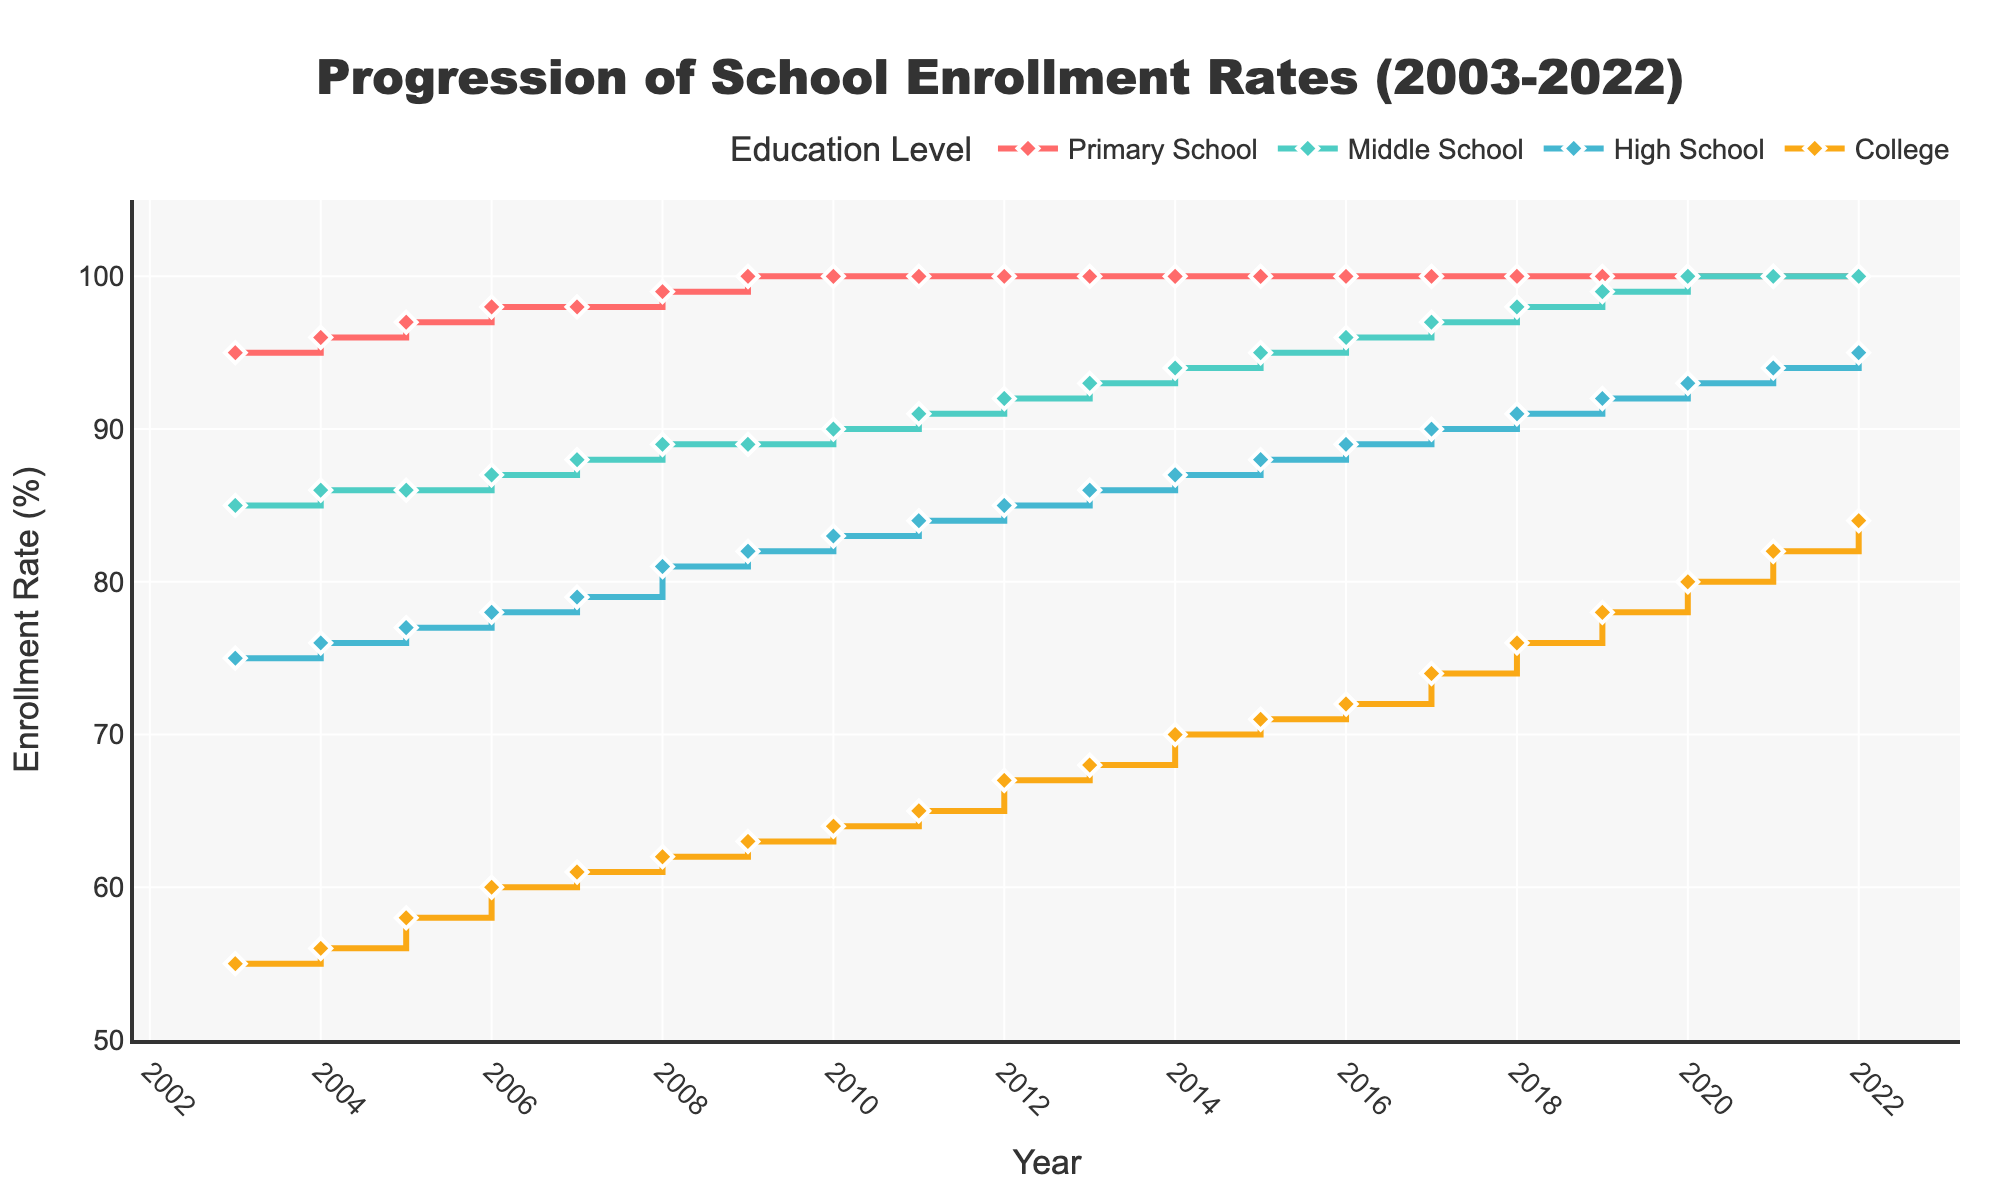what is the range of the y-axis on the figure? The y-axis runs from 50 to 105 percent, as shown by the axis labels and tick marks
Answer: 50 to 105 how does the enrollment rate for high school change from 2008 to 2012? In 2008, the rate is 81%. In 2012, it's 85%. The difference is 85% - 81% = 4%
Answer: 4% increase which education level has consistently reached full enrollment over the years? Observing the lines, the Primary School level reaches 100% enrollment consistently from 2009 onward
Answer: Primary School between what years did the middle school enrollment rate increase from 86% to 92%? Middle School enrollment rate increased from 86% in 2004 to 92% in 2012
Answer: 2004 to 2012 in what year did middle school and high school enrollment rates both reach 100%? In 2020, both Middle School and High School lines hit 100% as seen in the markers
Answer: 2020 how many years did it take for college enrollment rates to go from 55% to 84%? Starting in 2003 with 55% and reaching 84% in 2022, it took from 2003 to 2022, which is 19 years
Answer: 19 years which education level shows the steepest rise in enrollment rates over the 20 years? By comparing the slope of the lines, College shows the steepest rise as it starts at a lower rate and ends much higher
Answer: College what is the enrollment rate difference between primary school and college in 2017? In 2017, Primary School is at 100% and College is at 74%. The difference is 100% - 74% = 26%
Answer: 26% are there any education levels that show no further increase once full enrollment is achieved? Both Primary School and Middle School show no further increase once they hit 100%; the lines plateau
Answer: Primary School and Middle School how do the lines visually indicate the "stair" plot format? The lines display horizontal segments followed by vertical steps, creating a stair-like appearance
Answer: horizontal segments with vertical steps 